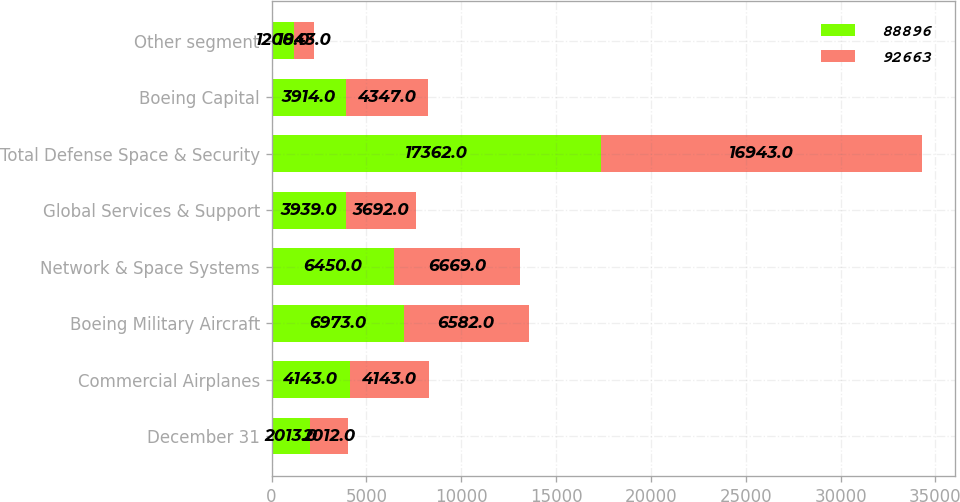<chart> <loc_0><loc_0><loc_500><loc_500><stacked_bar_chart><ecel><fcel>December 31<fcel>Commercial Airplanes<fcel>Boeing Military Aircraft<fcel>Network & Space Systems<fcel>Global Services & Support<fcel>Total Defense Space & Security<fcel>Boeing Capital<fcel>Other segment<nl><fcel>88896<fcel>2013<fcel>4143<fcel>6973<fcel>6450<fcel>3939<fcel>17362<fcel>3914<fcel>1208<nl><fcel>92663<fcel>2012<fcel>4143<fcel>6582<fcel>6669<fcel>3692<fcel>16943<fcel>4347<fcel>1043<nl></chart> 